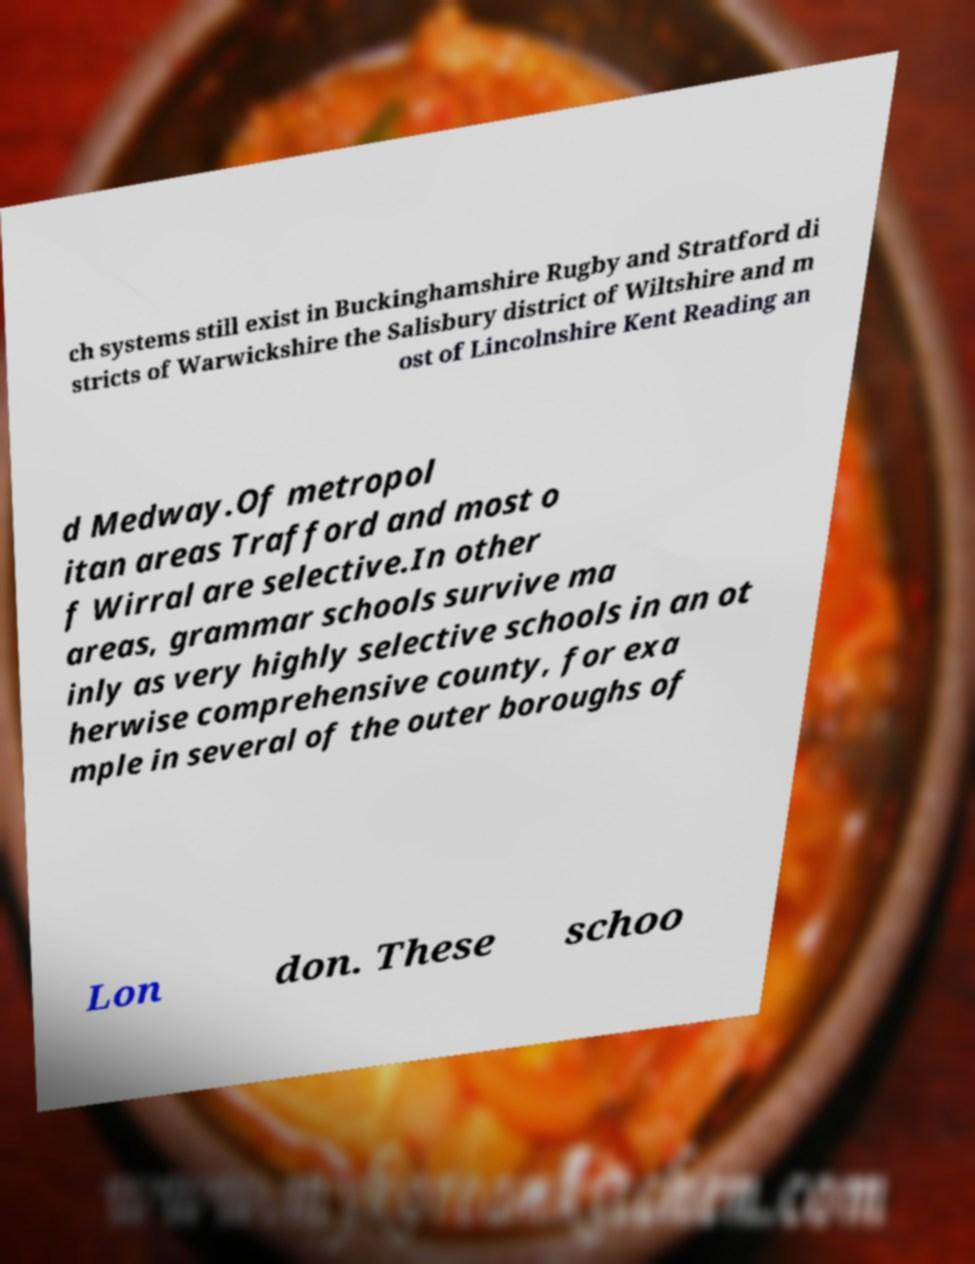Can you read and provide the text displayed in the image?This photo seems to have some interesting text. Can you extract and type it out for me? ch systems still exist in Buckinghamshire Rugby and Stratford di stricts of Warwickshire the Salisbury district of Wiltshire and m ost of Lincolnshire Kent Reading an d Medway.Of metropol itan areas Trafford and most o f Wirral are selective.In other areas, grammar schools survive ma inly as very highly selective schools in an ot herwise comprehensive county, for exa mple in several of the outer boroughs of Lon don. These schoo 